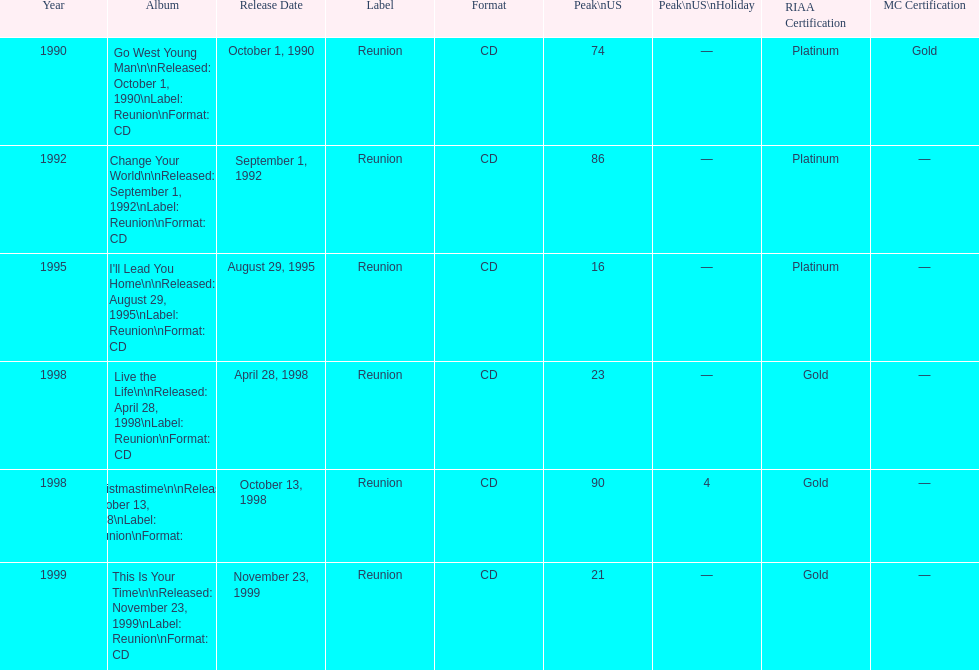How many album entries are there? 6. 